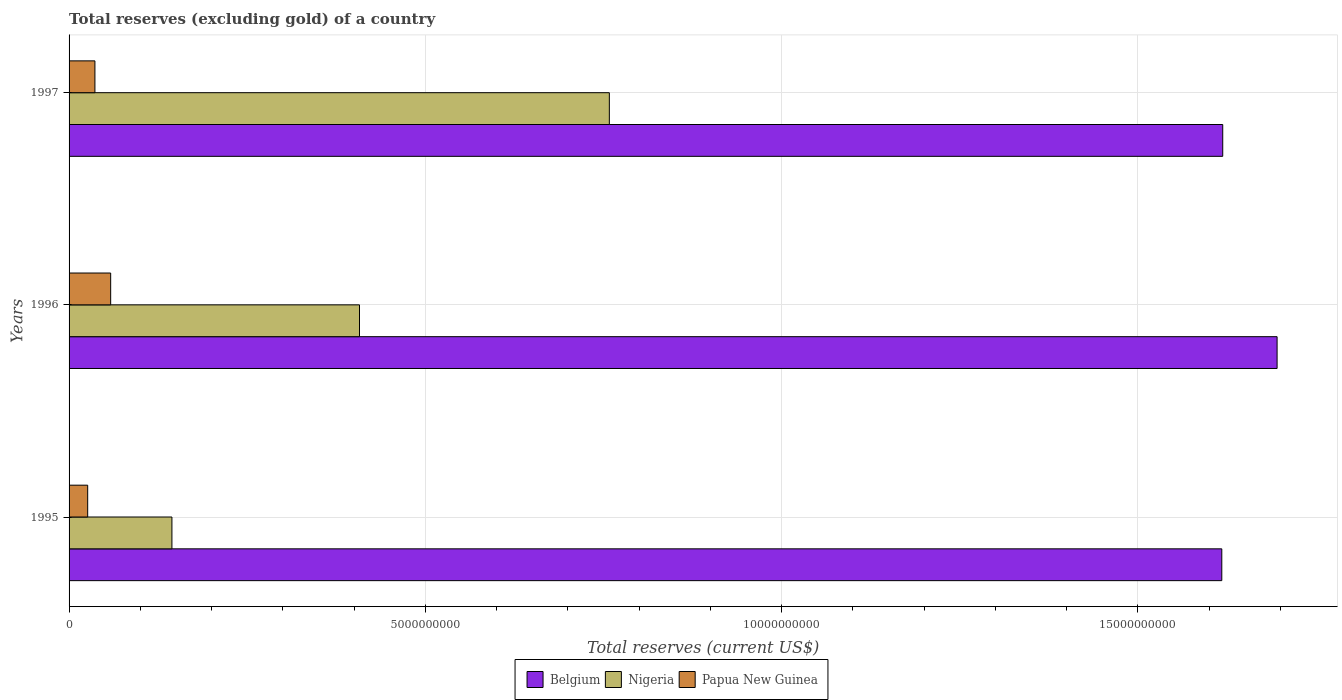How many groups of bars are there?
Provide a short and direct response. 3. Are the number of bars per tick equal to the number of legend labels?
Ensure brevity in your answer.  Yes. How many bars are there on the 2nd tick from the top?
Ensure brevity in your answer.  3. In how many cases, is the number of bars for a given year not equal to the number of legend labels?
Offer a terse response. 0. What is the total reserves (excluding gold) in Nigeria in 1996?
Make the answer very short. 4.08e+09. Across all years, what is the maximum total reserves (excluding gold) in Papua New Guinea?
Provide a short and direct response. 5.84e+08. Across all years, what is the minimum total reserves (excluding gold) in Papua New Guinea?
Make the answer very short. 2.61e+08. In which year was the total reserves (excluding gold) in Belgium maximum?
Ensure brevity in your answer.  1996. In which year was the total reserves (excluding gold) in Papua New Guinea minimum?
Give a very brief answer. 1995. What is the total total reserves (excluding gold) in Papua New Guinea in the graph?
Your answer should be very brief. 1.21e+09. What is the difference between the total reserves (excluding gold) in Belgium in 1995 and that in 1996?
Provide a short and direct response. -7.76e+08. What is the difference between the total reserves (excluding gold) in Belgium in 1996 and the total reserves (excluding gold) in Nigeria in 1997?
Ensure brevity in your answer.  9.37e+09. What is the average total reserves (excluding gold) in Papua New Guinea per year?
Your answer should be very brief. 4.03e+08. In the year 1995, what is the difference between the total reserves (excluding gold) in Nigeria and total reserves (excluding gold) in Papua New Guinea?
Provide a short and direct response. 1.18e+09. What is the ratio of the total reserves (excluding gold) in Papua New Guinea in 1996 to that in 1997?
Your response must be concise. 1.61. Is the total reserves (excluding gold) in Nigeria in 1995 less than that in 1996?
Ensure brevity in your answer.  Yes. Is the difference between the total reserves (excluding gold) in Nigeria in 1995 and 1996 greater than the difference between the total reserves (excluding gold) in Papua New Guinea in 1995 and 1996?
Offer a very short reply. No. What is the difference between the highest and the second highest total reserves (excluding gold) in Belgium?
Your response must be concise. 7.63e+08. What is the difference between the highest and the lowest total reserves (excluding gold) in Papua New Guinea?
Offer a terse response. 3.23e+08. In how many years, is the total reserves (excluding gold) in Belgium greater than the average total reserves (excluding gold) in Belgium taken over all years?
Your response must be concise. 1. Is the sum of the total reserves (excluding gold) in Papua New Guinea in 1995 and 1996 greater than the maximum total reserves (excluding gold) in Belgium across all years?
Provide a succinct answer. No. Are all the bars in the graph horizontal?
Your response must be concise. Yes. What is the difference between two consecutive major ticks on the X-axis?
Offer a very short reply. 5.00e+09. Are the values on the major ticks of X-axis written in scientific E-notation?
Offer a very short reply. No. Does the graph contain any zero values?
Offer a very short reply. No. What is the title of the graph?
Provide a succinct answer. Total reserves (excluding gold) of a country. What is the label or title of the X-axis?
Your response must be concise. Total reserves (current US$). What is the label or title of the Y-axis?
Provide a short and direct response. Years. What is the Total reserves (current US$) in Belgium in 1995?
Ensure brevity in your answer.  1.62e+1. What is the Total reserves (current US$) in Nigeria in 1995?
Ensure brevity in your answer.  1.44e+09. What is the Total reserves (current US$) in Papua New Guinea in 1995?
Make the answer very short. 2.61e+08. What is the Total reserves (current US$) in Belgium in 1996?
Provide a short and direct response. 1.70e+1. What is the Total reserves (current US$) in Nigeria in 1996?
Your answer should be compact. 4.08e+09. What is the Total reserves (current US$) of Papua New Guinea in 1996?
Ensure brevity in your answer.  5.84e+08. What is the Total reserves (current US$) of Belgium in 1997?
Make the answer very short. 1.62e+1. What is the Total reserves (current US$) in Nigeria in 1997?
Your response must be concise. 7.58e+09. What is the Total reserves (current US$) of Papua New Guinea in 1997?
Provide a succinct answer. 3.63e+08. Across all years, what is the maximum Total reserves (current US$) in Belgium?
Keep it short and to the point. 1.70e+1. Across all years, what is the maximum Total reserves (current US$) of Nigeria?
Give a very brief answer. 7.58e+09. Across all years, what is the maximum Total reserves (current US$) in Papua New Guinea?
Your response must be concise. 5.84e+08. Across all years, what is the minimum Total reserves (current US$) of Belgium?
Offer a terse response. 1.62e+1. Across all years, what is the minimum Total reserves (current US$) in Nigeria?
Provide a short and direct response. 1.44e+09. Across all years, what is the minimum Total reserves (current US$) in Papua New Guinea?
Provide a succinct answer. 2.61e+08. What is the total Total reserves (current US$) of Belgium in the graph?
Make the answer very short. 4.93e+1. What is the total Total reserves (current US$) in Nigeria in the graph?
Offer a very short reply. 1.31e+1. What is the total Total reserves (current US$) of Papua New Guinea in the graph?
Your answer should be very brief. 1.21e+09. What is the difference between the Total reserves (current US$) in Belgium in 1995 and that in 1996?
Your response must be concise. -7.76e+08. What is the difference between the Total reserves (current US$) in Nigeria in 1995 and that in 1996?
Offer a terse response. -2.63e+09. What is the difference between the Total reserves (current US$) in Papua New Guinea in 1995 and that in 1996?
Provide a short and direct response. -3.23e+08. What is the difference between the Total reserves (current US$) in Belgium in 1995 and that in 1997?
Your response must be concise. -1.32e+07. What is the difference between the Total reserves (current US$) of Nigeria in 1995 and that in 1997?
Provide a short and direct response. -6.14e+09. What is the difference between the Total reserves (current US$) in Papua New Guinea in 1995 and that in 1997?
Your answer should be very brief. -1.01e+08. What is the difference between the Total reserves (current US$) of Belgium in 1996 and that in 1997?
Your answer should be compact. 7.63e+08. What is the difference between the Total reserves (current US$) of Nigeria in 1996 and that in 1997?
Provide a short and direct response. -3.51e+09. What is the difference between the Total reserves (current US$) of Papua New Guinea in 1996 and that in 1997?
Your response must be concise. 2.21e+08. What is the difference between the Total reserves (current US$) of Belgium in 1995 and the Total reserves (current US$) of Nigeria in 1996?
Make the answer very short. 1.21e+1. What is the difference between the Total reserves (current US$) of Belgium in 1995 and the Total reserves (current US$) of Papua New Guinea in 1996?
Offer a very short reply. 1.56e+1. What is the difference between the Total reserves (current US$) of Nigeria in 1995 and the Total reserves (current US$) of Papua New Guinea in 1996?
Offer a terse response. 8.60e+08. What is the difference between the Total reserves (current US$) in Belgium in 1995 and the Total reserves (current US$) in Nigeria in 1997?
Ensure brevity in your answer.  8.59e+09. What is the difference between the Total reserves (current US$) in Belgium in 1995 and the Total reserves (current US$) in Papua New Guinea in 1997?
Your response must be concise. 1.58e+1. What is the difference between the Total reserves (current US$) in Nigeria in 1995 and the Total reserves (current US$) in Papua New Guinea in 1997?
Make the answer very short. 1.08e+09. What is the difference between the Total reserves (current US$) in Belgium in 1996 and the Total reserves (current US$) in Nigeria in 1997?
Provide a succinct answer. 9.37e+09. What is the difference between the Total reserves (current US$) of Belgium in 1996 and the Total reserves (current US$) of Papua New Guinea in 1997?
Provide a succinct answer. 1.66e+1. What is the difference between the Total reserves (current US$) in Nigeria in 1996 and the Total reserves (current US$) in Papua New Guinea in 1997?
Provide a short and direct response. 3.71e+09. What is the average Total reserves (current US$) of Belgium per year?
Keep it short and to the point. 1.64e+1. What is the average Total reserves (current US$) in Nigeria per year?
Give a very brief answer. 4.37e+09. What is the average Total reserves (current US$) of Papua New Guinea per year?
Offer a very short reply. 4.03e+08. In the year 1995, what is the difference between the Total reserves (current US$) of Belgium and Total reserves (current US$) of Nigeria?
Make the answer very short. 1.47e+1. In the year 1995, what is the difference between the Total reserves (current US$) of Belgium and Total reserves (current US$) of Papua New Guinea?
Provide a short and direct response. 1.59e+1. In the year 1995, what is the difference between the Total reserves (current US$) in Nigeria and Total reserves (current US$) in Papua New Guinea?
Provide a succinct answer. 1.18e+09. In the year 1996, what is the difference between the Total reserves (current US$) of Belgium and Total reserves (current US$) of Nigeria?
Give a very brief answer. 1.29e+1. In the year 1996, what is the difference between the Total reserves (current US$) of Belgium and Total reserves (current US$) of Papua New Guinea?
Your response must be concise. 1.64e+1. In the year 1996, what is the difference between the Total reserves (current US$) in Nigeria and Total reserves (current US$) in Papua New Guinea?
Provide a succinct answer. 3.49e+09. In the year 1997, what is the difference between the Total reserves (current US$) of Belgium and Total reserves (current US$) of Nigeria?
Your response must be concise. 8.61e+09. In the year 1997, what is the difference between the Total reserves (current US$) of Belgium and Total reserves (current US$) of Papua New Guinea?
Keep it short and to the point. 1.58e+1. In the year 1997, what is the difference between the Total reserves (current US$) in Nigeria and Total reserves (current US$) in Papua New Guinea?
Your response must be concise. 7.22e+09. What is the ratio of the Total reserves (current US$) in Belgium in 1995 to that in 1996?
Your answer should be very brief. 0.95. What is the ratio of the Total reserves (current US$) in Nigeria in 1995 to that in 1996?
Your response must be concise. 0.35. What is the ratio of the Total reserves (current US$) in Papua New Guinea in 1995 to that in 1996?
Your response must be concise. 0.45. What is the ratio of the Total reserves (current US$) in Belgium in 1995 to that in 1997?
Offer a terse response. 1. What is the ratio of the Total reserves (current US$) of Nigeria in 1995 to that in 1997?
Provide a short and direct response. 0.19. What is the ratio of the Total reserves (current US$) of Papua New Guinea in 1995 to that in 1997?
Your answer should be very brief. 0.72. What is the ratio of the Total reserves (current US$) of Belgium in 1996 to that in 1997?
Your answer should be very brief. 1.05. What is the ratio of the Total reserves (current US$) in Nigeria in 1996 to that in 1997?
Offer a terse response. 0.54. What is the ratio of the Total reserves (current US$) in Papua New Guinea in 1996 to that in 1997?
Make the answer very short. 1.61. What is the difference between the highest and the second highest Total reserves (current US$) of Belgium?
Offer a terse response. 7.63e+08. What is the difference between the highest and the second highest Total reserves (current US$) of Nigeria?
Make the answer very short. 3.51e+09. What is the difference between the highest and the second highest Total reserves (current US$) in Papua New Guinea?
Ensure brevity in your answer.  2.21e+08. What is the difference between the highest and the lowest Total reserves (current US$) of Belgium?
Your answer should be very brief. 7.76e+08. What is the difference between the highest and the lowest Total reserves (current US$) in Nigeria?
Give a very brief answer. 6.14e+09. What is the difference between the highest and the lowest Total reserves (current US$) in Papua New Guinea?
Offer a terse response. 3.23e+08. 